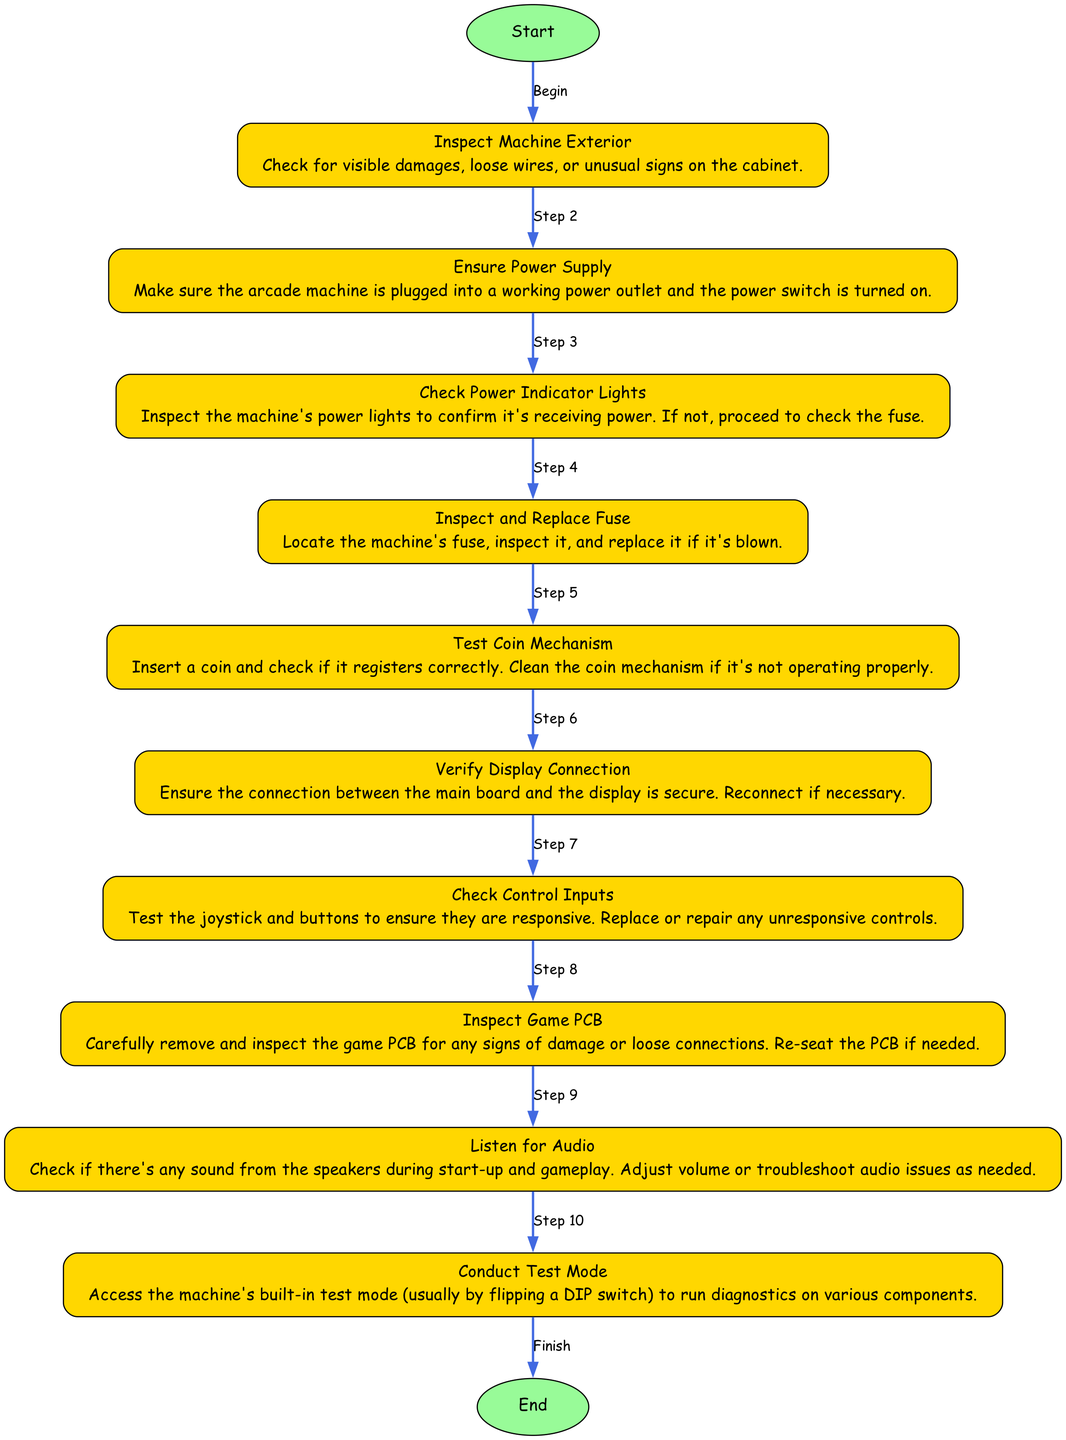What is the first step in the troubleshooting process? The first step in the diagram is labeled "Inspect Machine Exterior," indicating that this is where the troubleshooting begins.
Answer: Inspect Machine Exterior How many nodes are present in the diagram? The diagram consists of 10 steps, including the start and end nodes. Therefore, the total number of nodes is 12.
Answer: 12 What action follows "Ensure Power Supply"? Immediately after "Ensure Power Supply," the next action listed in the diagram is "Check Power Indicator Lights."
Answer: Check Power Indicator Lights What does the last step in the process instruct you to do? The final step in the diagram leads to the "End" node, which signifies the conclusion of the troubleshooting process without further instructions.
Answer: End How does one verify the display connection? According to the diagram, the action following "Ensure Power Supply" is "Verify Display Connection," which involves checking whether the connection between the main board and the display is secure.
Answer: Ensure the connection between the main board and the display is secure Which step involves listening for sound? The step labeled "Listen for Audio" is specifically focused on checking for sound coming from the speakers during start-up and gameplay.
Answer: Listen for Audio What action is taken if the coin mechanism is not working properly? If the coin mechanism is found to be ineffective, the diagram suggests cleaning the coin mechanism to ensure it registers coins correctly.
Answer: Clean the coin mechanism What is the purpose of conducting the test mode? The "Conduct Test Mode" step is intended to access the machine's built-in test mode to run diagnostics on various components, ensuring all systems function properly.
Answer: Run diagnostics on various components 